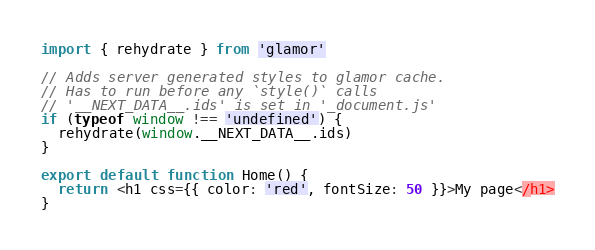<code> <loc_0><loc_0><loc_500><loc_500><_JavaScript_>import { rehydrate } from 'glamor'

// Adds server generated styles to glamor cache.
// Has to run before any `style()` calls
// '__NEXT_DATA__.ids' is set in '_document.js'
if (typeof window !== 'undefined') {
  rehydrate(window.__NEXT_DATA__.ids)
}

export default function Home() {
  return <h1 css={{ color: 'red', fontSize: 50 }}>My page</h1>
}
</code> 